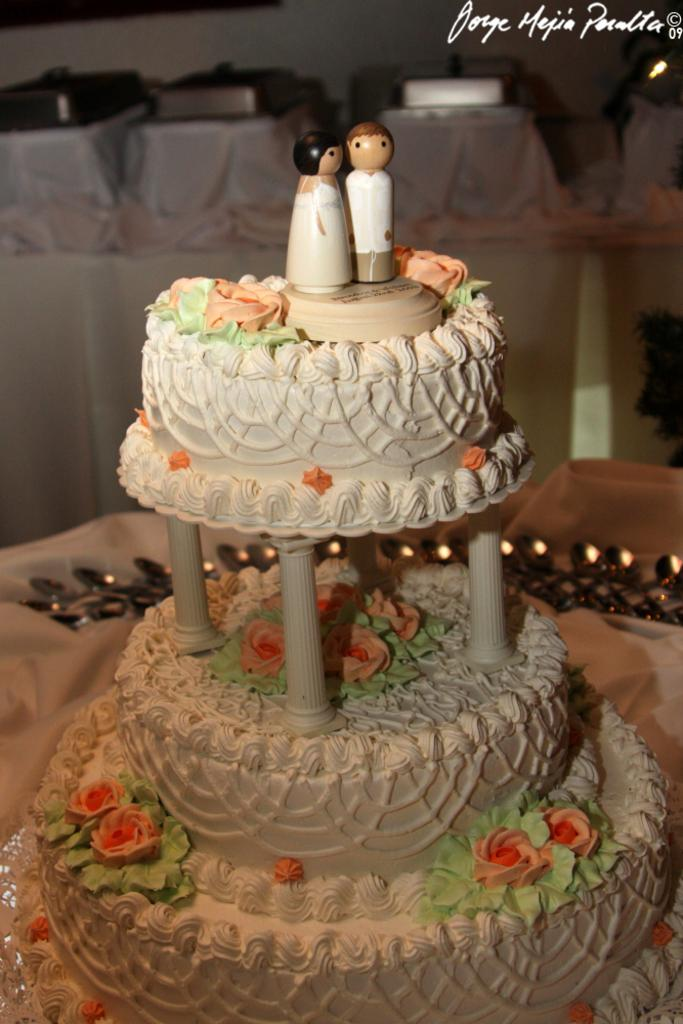What is the main subject of the image? There is a cake on a table in the image. Can you describe anything else visible in the image? There are objects visible in the background of the image. Is there any additional information about the image itself? Yes, there is a watermark present in the image. What is the value of the hook in the aftermath of the image? There is no hook or aftermath present in the image; it features a cake on a table and objects in the background. 